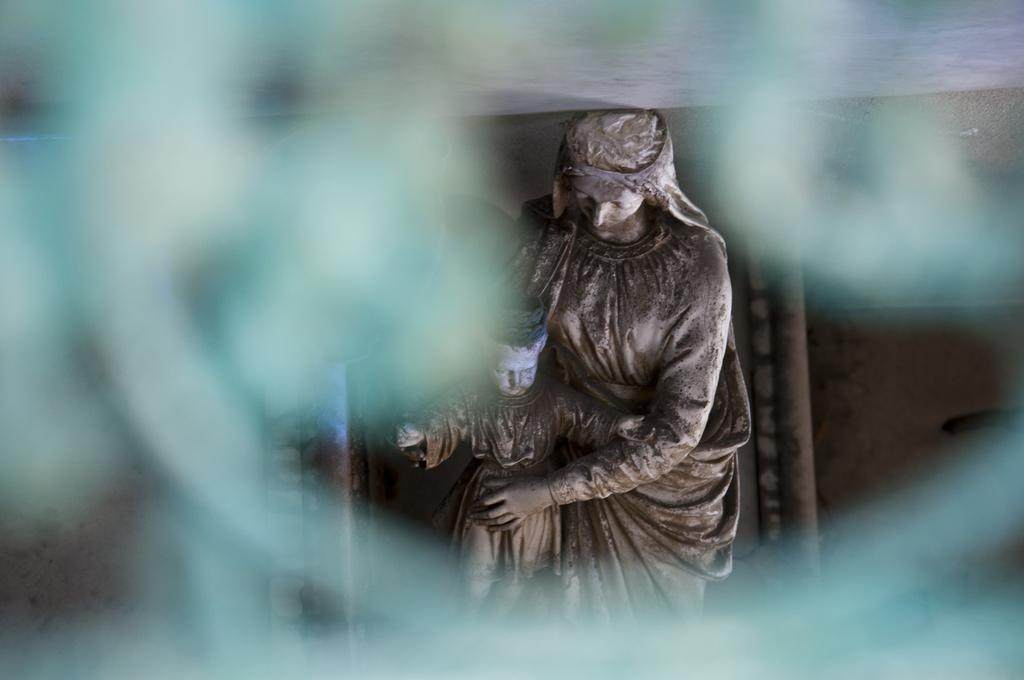What type of art is present in the image? There are sculptures in the image. Can you describe the surroundings of the sculptures? The surroundings of the sculptures are blurry. What type of argument can be seen taking place between the sculptures in the image? There is no argument present between the sculptures in the image; they are inanimate objects. What type of industry is depicted in the image? There is no industry depicted in the image; it features sculptures and blurry surroundings. 